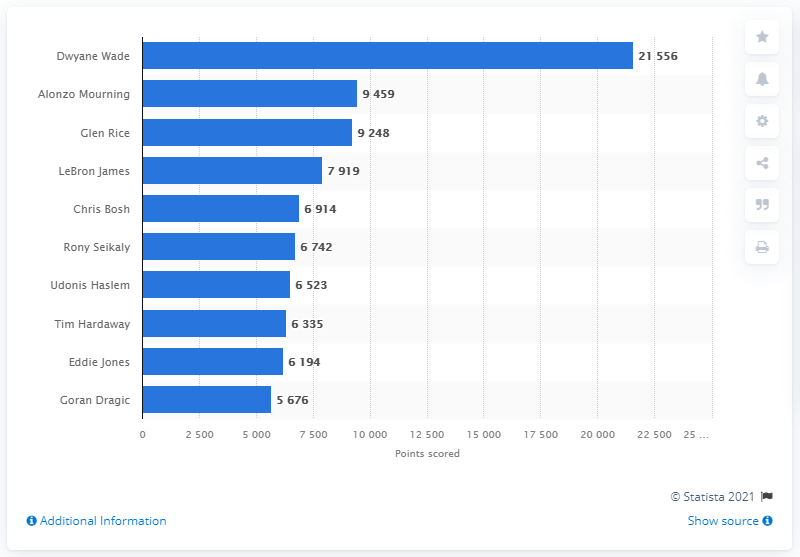Indicate a few pertinent items in this graphic. Dwyane Wade is the career points leader of the Miami Heat. 